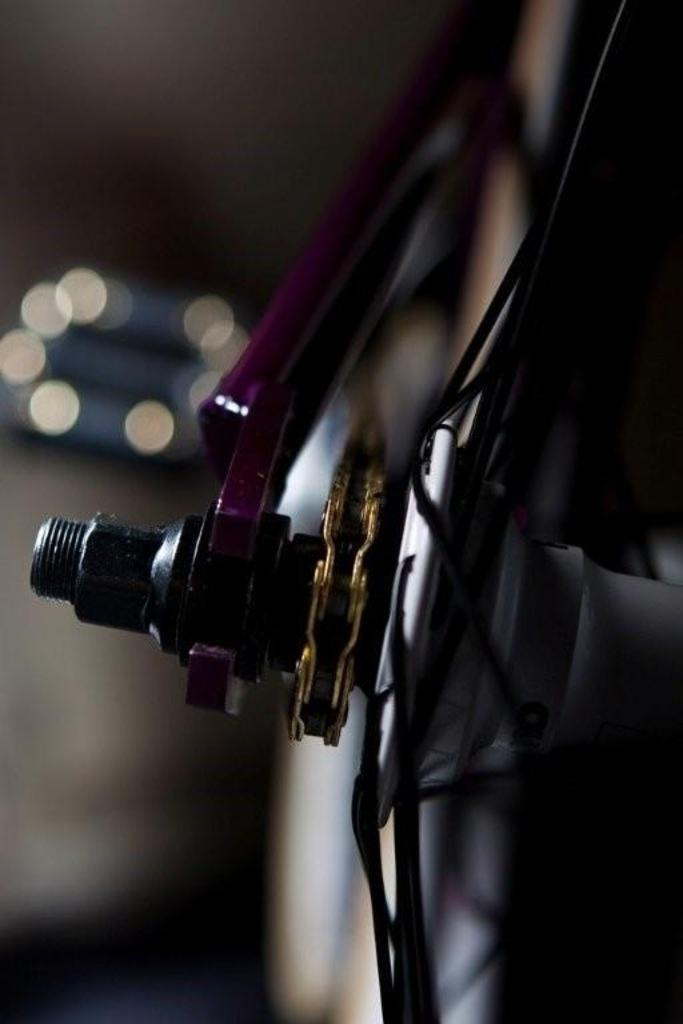What type of wheel is visible in the image? There is a spoke wheel in the image. What structure is associated with the spoke wheel? There is a frame in the image. What type of fastener is present in the image? There is a nut and a bolt in the image. Can you see a river flowing through the image? There is no river present in the image. Is there a light source illuminating the objects in the image? The image does not show any light source; it only depicts the spoke wheel, frame, nut, and bolt. 